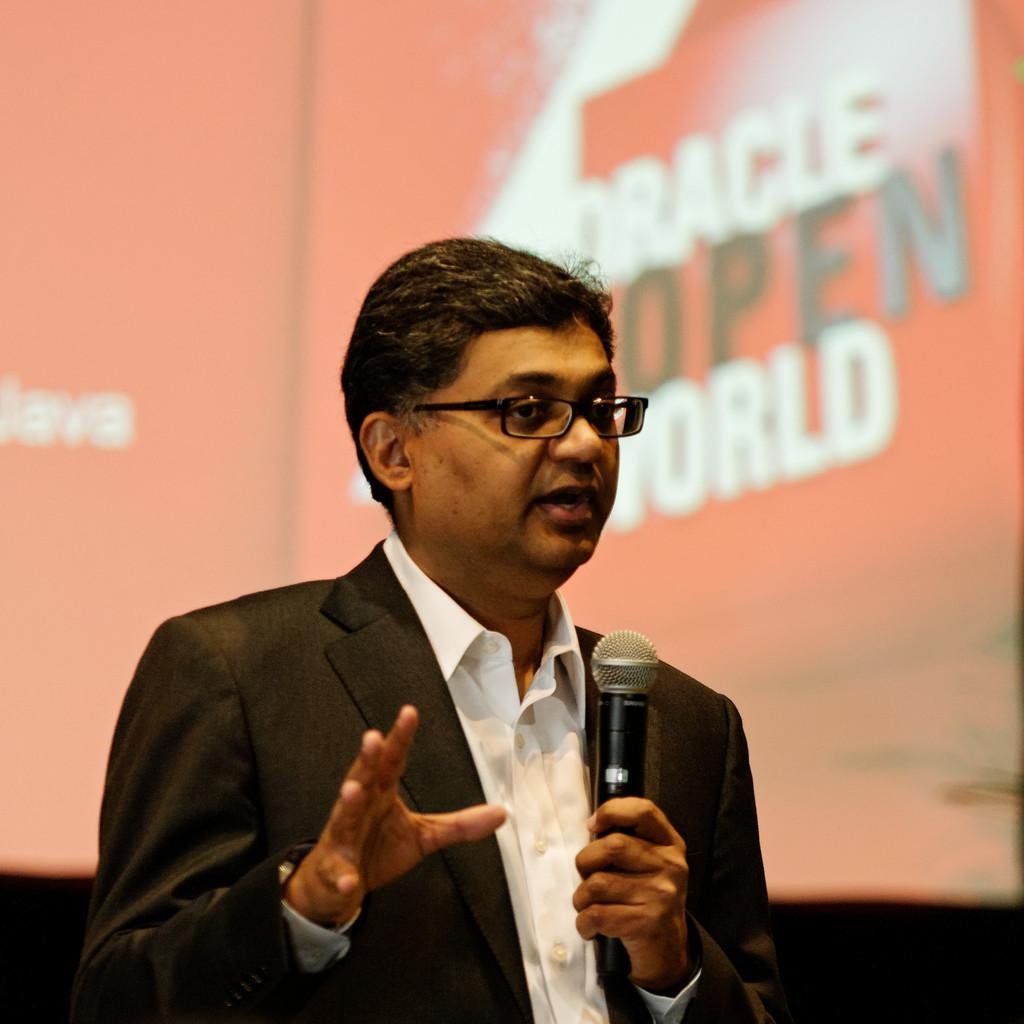What is the person in the image doing? The person is holding a microphone. Can you describe the person's appearance? The person is wearing glasses. What can be seen in the background of the image? There is an orange-colored board in the background. What is written on the board? There is text on the board. What type of lettuce is being delivered in the parcel seen in the image? There is no lettuce or parcel present in the image. How many yams are visible on the person's head in the image? There are no yams present in the image. 